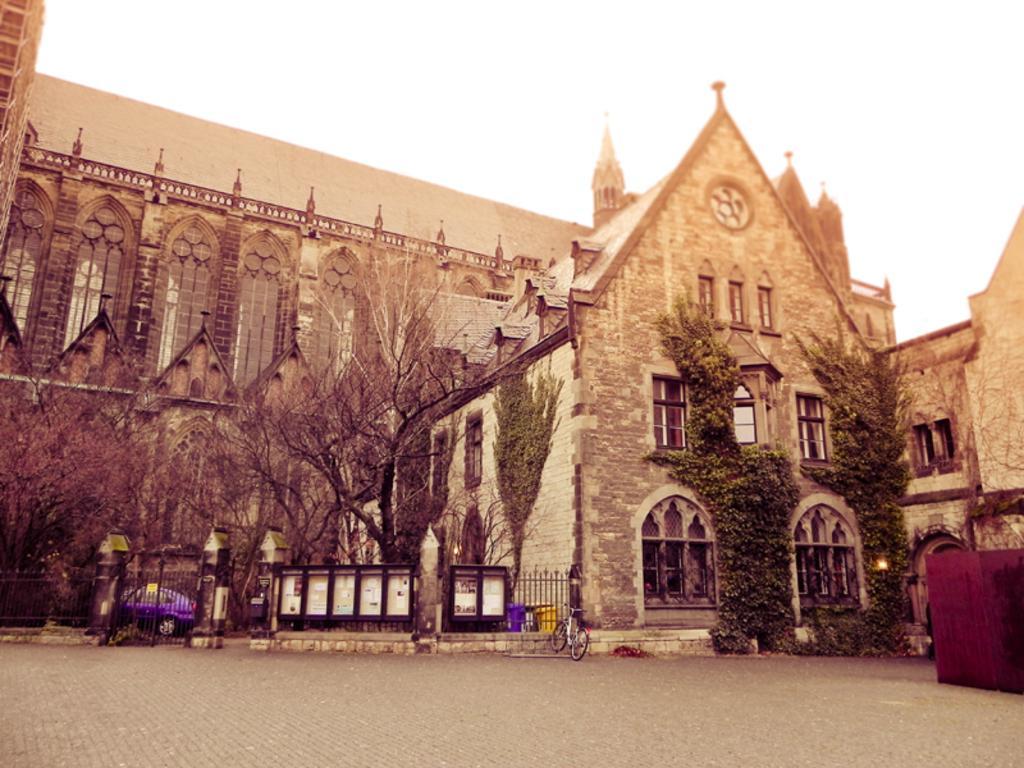Could you give a brief overview of what you see in this image? This image is taken outdoors. At the top of the image there is the sky. At the bottom of the image there is a floor. In the middle of the image there is a building with walls, windows, doors, carvings, railings and a roof. There are a few trees with stems and branches. There are a few creepers with green leaves and there is a light. There is a railing. There are a few boards. A car is parked on the ground and a bicycle is parked on the floor. 